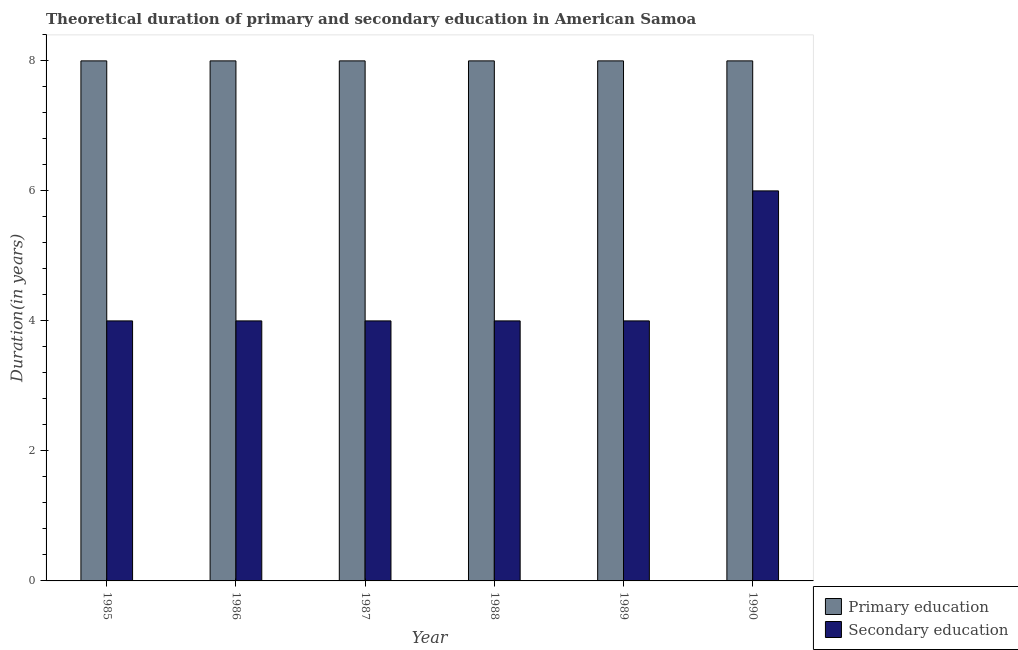How many different coloured bars are there?
Ensure brevity in your answer.  2. How many groups of bars are there?
Provide a short and direct response. 6. How many bars are there on the 1st tick from the left?
Ensure brevity in your answer.  2. In how many cases, is the number of bars for a given year not equal to the number of legend labels?
Your response must be concise. 0. What is the duration of secondary education in 1989?
Your answer should be compact. 4. Across all years, what is the maximum duration of primary education?
Your answer should be very brief. 8. Across all years, what is the minimum duration of primary education?
Ensure brevity in your answer.  8. In which year was the duration of secondary education maximum?
Keep it short and to the point. 1990. In which year was the duration of primary education minimum?
Keep it short and to the point. 1985. What is the total duration of secondary education in the graph?
Offer a very short reply. 26. What is the difference between the duration of secondary education in 1986 and that in 1989?
Ensure brevity in your answer.  0. What is the ratio of the duration of secondary education in 1985 to that in 1986?
Ensure brevity in your answer.  1. What is the difference between the highest and the second highest duration of primary education?
Keep it short and to the point. 0. In how many years, is the duration of secondary education greater than the average duration of secondary education taken over all years?
Your answer should be compact. 1. Is the sum of the duration of secondary education in 1985 and 1988 greater than the maximum duration of primary education across all years?
Offer a terse response. Yes. What does the 2nd bar from the right in 1986 represents?
Ensure brevity in your answer.  Primary education. How many years are there in the graph?
Offer a very short reply. 6. Are the values on the major ticks of Y-axis written in scientific E-notation?
Keep it short and to the point. No. How many legend labels are there?
Ensure brevity in your answer.  2. How are the legend labels stacked?
Provide a succinct answer. Vertical. What is the title of the graph?
Your answer should be very brief. Theoretical duration of primary and secondary education in American Samoa. Does "Gasoline" appear as one of the legend labels in the graph?
Your response must be concise. No. What is the label or title of the X-axis?
Ensure brevity in your answer.  Year. What is the label or title of the Y-axis?
Provide a short and direct response. Duration(in years). What is the Duration(in years) of Secondary education in 1987?
Your answer should be compact. 4. What is the Duration(in years) of Primary education in 1989?
Provide a succinct answer. 8. Across all years, what is the maximum Duration(in years) of Primary education?
Your response must be concise. 8. What is the total Duration(in years) in Primary education in the graph?
Keep it short and to the point. 48. What is the difference between the Duration(in years) of Primary education in 1985 and that in 1986?
Offer a terse response. 0. What is the difference between the Duration(in years) of Primary education in 1985 and that in 1987?
Provide a succinct answer. 0. What is the difference between the Duration(in years) of Primary education in 1985 and that in 1988?
Your answer should be compact. 0. What is the difference between the Duration(in years) in Secondary education in 1985 and that in 1988?
Give a very brief answer. 0. What is the difference between the Duration(in years) of Primary education in 1985 and that in 1989?
Offer a terse response. 0. What is the difference between the Duration(in years) in Primary education in 1986 and that in 1988?
Make the answer very short. 0. What is the difference between the Duration(in years) of Primary education in 1987 and that in 1988?
Your answer should be compact. 0. What is the difference between the Duration(in years) in Primary education in 1987 and that in 1989?
Give a very brief answer. 0. What is the difference between the Duration(in years) in Secondary education in 1987 and that in 1989?
Keep it short and to the point. 0. What is the difference between the Duration(in years) of Primary education in 1987 and that in 1990?
Offer a terse response. 0. What is the difference between the Duration(in years) in Primary education in 1988 and that in 1989?
Provide a succinct answer. 0. What is the difference between the Duration(in years) in Secondary education in 1988 and that in 1989?
Your answer should be compact. 0. What is the difference between the Duration(in years) of Primary education in 1989 and that in 1990?
Offer a very short reply. 0. What is the difference between the Duration(in years) of Secondary education in 1989 and that in 1990?
Offer a terse response. -2. What is the difference between the Duration(in years) of Primary education in 1985 and the Duration(in years) of Secondary education in 1986?
Provide a succinct answer. 4. What is the difference between the Duration(in years) of Primary education in 1985 and the Duration(in years) of Secondary education in 1988?
Provide a succinct answer. 4. What is the difference between the Duration(in years) of Primary education in 1985 and the Duration(in years) of Secondary education in 1989?
Your response must be concise. 4. What is the difference between the Duration(in years) of Primary education in 1985 and the Duration(in years) of Secondary education in 1990?
Provide a short and direct response. 2. What is the difference between the Duration(in years) in Primary education in 1986 and the Duration(in years) in Secondary education in 1988?
Your response must be concise. 4. What is the average Duration(in years) of Primary education per year?
Your answer should be very brief. 8. What is the average Duration(in years) of Secondary education per year?
Provide a succinct answer. 4.33. In the year 1985, what is the difference between the Duration(in years) of Primary education and Duration(in years) of Secondary education?
Your answer should be compact. 4. What is the ratio of the Duration(in years) of Secondary education in 1985 to that in 1988?
Give a very brief answer. 1. What is the ratio of the Duration(in years) in Primary education in 1985 to that in 1989?
Provide a short and direct response. 1. What is the ratio of the Duration(in years) in Secondary education in 1985 to that in 1989?
Provide a short and direct response. 1. What is the ratio of the Duration(in years) in Secondary education in 1985 to that in 1990?
Offer a terse response. 0.67. What is the ratio of the Duration(in years) in Secondary education in 1986 to that in 1988?
Your response must be concise. 1. What is the ratio of the Duration(in years) of Primary education in 1986 to that in 1990?
Ensure brevity in your answer.  1. What is the ratio of the Duration(in years) in Primary education in 1987 to that in 1988?
Ensure brevity in your answer.  1. What is the ratio of the Duration(in years) of Secondary education in 1987 to that in 1988?
Keep it short and to the point. 1. What is the ratio of the Duration(in years) of Primary education in 1987 to that in 1989?
Provide a short and direct response. 1. What is the ratio of the Duration(in years) of Secondary education in 1987 to that in 1989?
Your answer should be very brief. 1. What is the ratio of the Duration(in years) in Secondary education in 1988 to that in 1989?
Your answer should be very brief. 1. What is the ratio of the Duration(in years) in Primary education in 1988 to that in 1990?
Your response must be concise. 1. What is the ratio of the Duration(in years) of Secondary education in 1988 to that in 1990?
Offer a very short reply. 0.67. What is the ratio of the Duration(in years) of Primary education in 1989 to that in 1990?
Ensure brevity in your answer.  1. What is the difference between the highest and the second highest Duration(in years) of Secondary education?
Provide a short and direct response. 2. What is the difference between the highest and the lowest Duration(in years) of Primary education?
Make the answer very short. 0. 